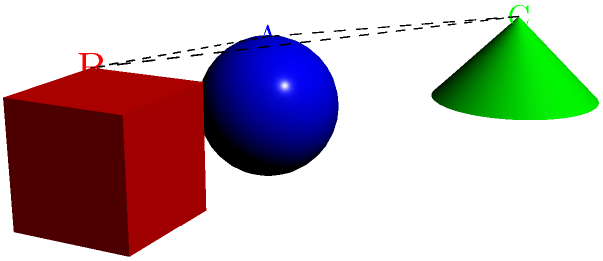In a collaborative development environment, three software modules are represented by 3D objects: a sphere (A), a cube (B), and a cone (C). If the cube is rotated 90 degrees clockwise around the z-axis (vertical axis), and the cone is rotated 180 degrees around the x-axis (horizontal axis), which module will be farthest from its original position relative to the others? To solve this problem, we need to mentally rotate the objects and visualize their new positions:

1. The sphere (A) remains stationary, serving as our reference point.

2. The cube (B) rotates 90 degrees clockwise around the z-axis:
   - This moves it from the right side of the sphere to behind the sphere.
   - The distance from A to B remains the same.

3. The cone (C) rotates 180 degrees around the x-axis:
   - This flips it upside down and moves it from the top-left of the sphere to the bottom-left.
   - The distance from A to C remains the same, but C's position relative to B changes significantly.

4. After rotation, B and C have both moved relative to each other:
   - B is now behind A instead of to its right.
   - C is now below and left of A instead of above and left.

5. The distance between B and C has increased the most because:
   - B moved behind A (along the y-axis).
   - C moved below A (along the z-axis).
   - This creates a diagonal distance that is greater than their original separation.

Therefore, the cone (C) will be farthest from its original position relative to the cube (B), while maintaining its distance from the sphere (A).
Answer: C (the cone) 